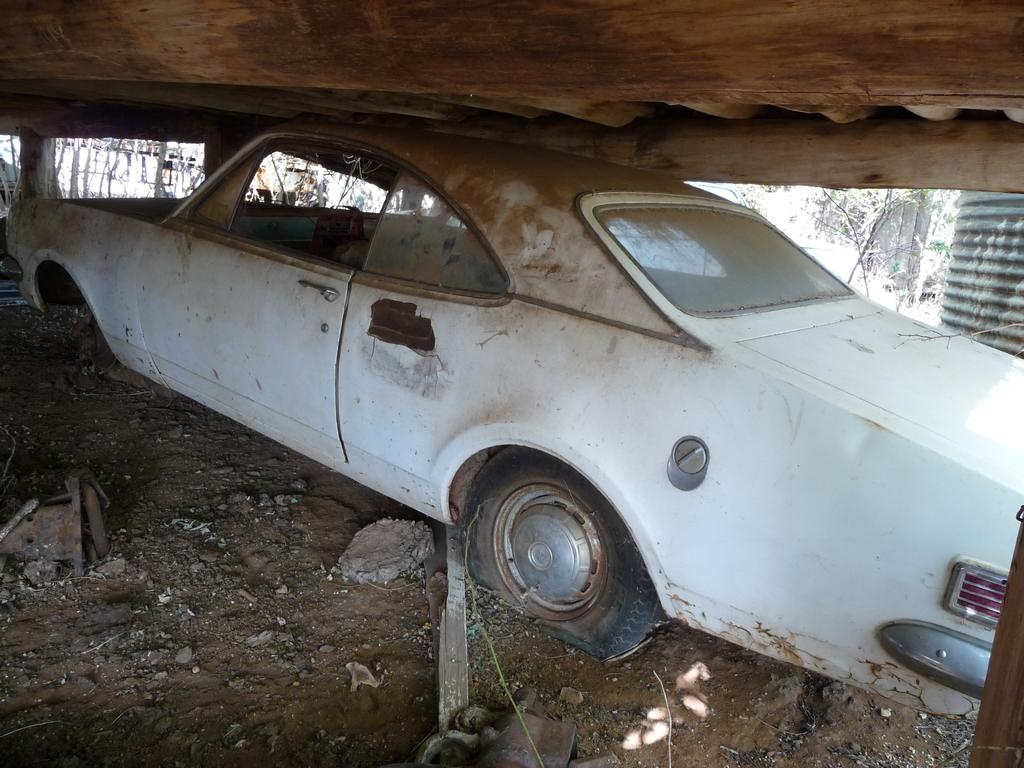What is the main subject of the image? The main subject of the image is a car. Can you describe the color of the car? The car is white in color. What type of produce is being harvested in the image? There is no produce present in the image; it features a white car. Where can the person be seen sleeping in the image? There is no person or sleeping area depicted in the image; it only shows a white car. 